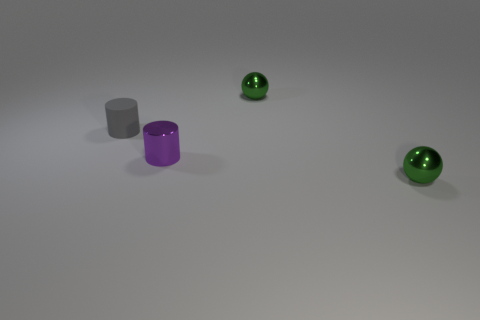If these objects were part of a still life art piece, what mood or theme might the artist be conveying? The cool color palette and simplistic arrangement of the objects could convey a modern and minimalist theme. The contrast between the matte and metallic textures might represent a juxtaposition between the natural and the industrial. The overall mood is calm and introspective, with a focus on form and material over complex narrative or emotion. 